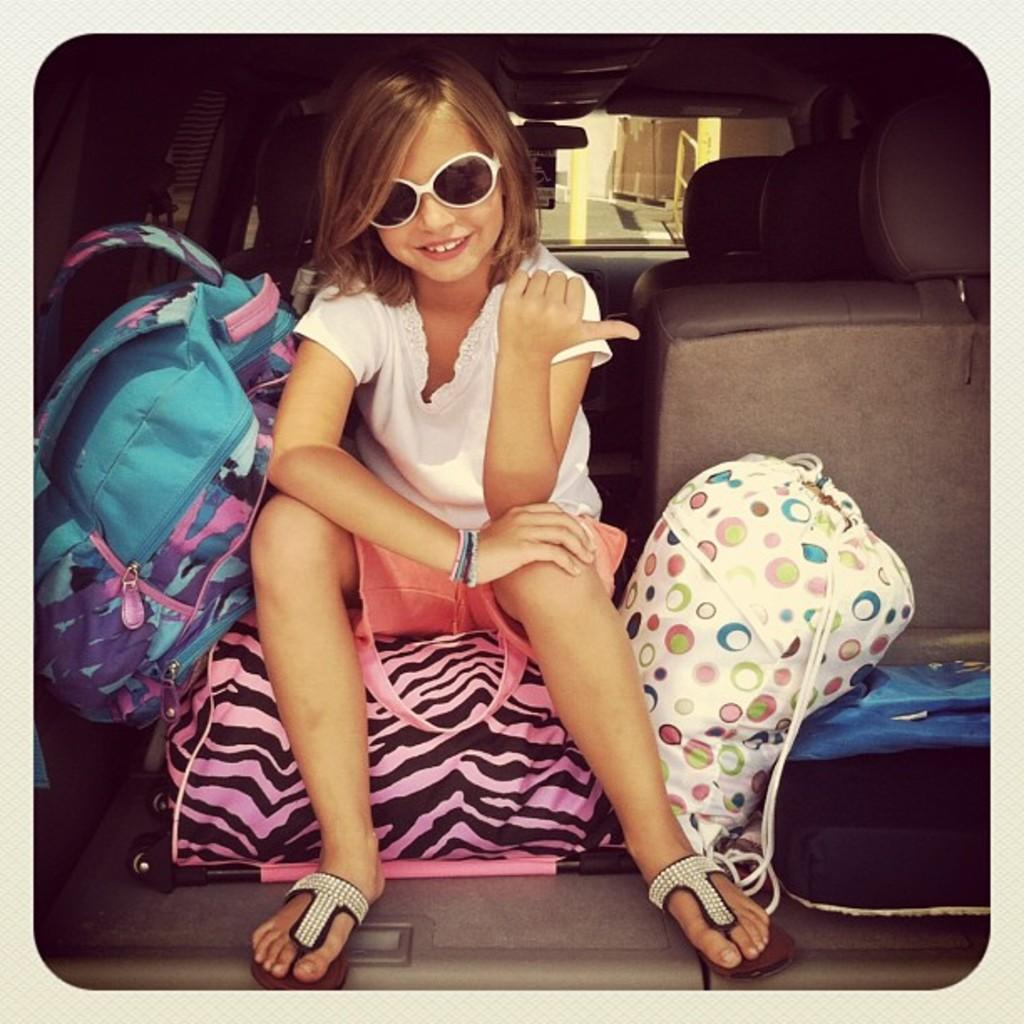Who is the main subject in the image? There is a girl in the image. What is the girl wearing? The girl is wearing spectacles. What is the girl sitting on? The girl is sitting on a bag. Can you identify any other objects in the image? Yes, there is a suitcase in the image. What type of letter is the girl holding in the image? There is no letter present in the image. 